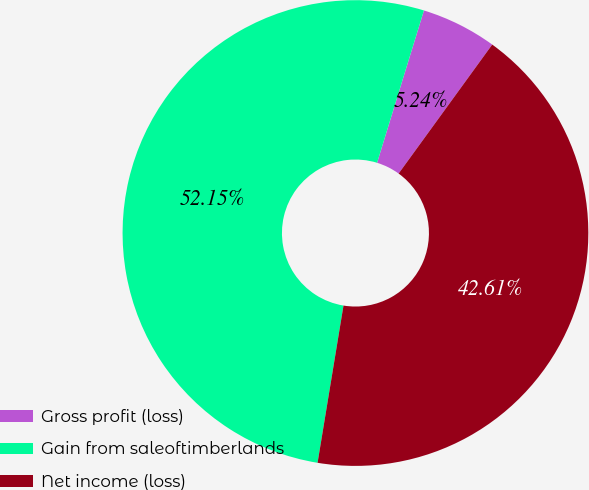Convert chart. <chart><loc_0><loc_0><loc_500><loc_500><pie_chart><fcel>Gross profit (loss)<fcel>Gain from saleoftimberlands<fcel>Net income (loss)<nl><fcel>5.24%<fcel>52.15%<fcel>42.61%<nl></chart> 